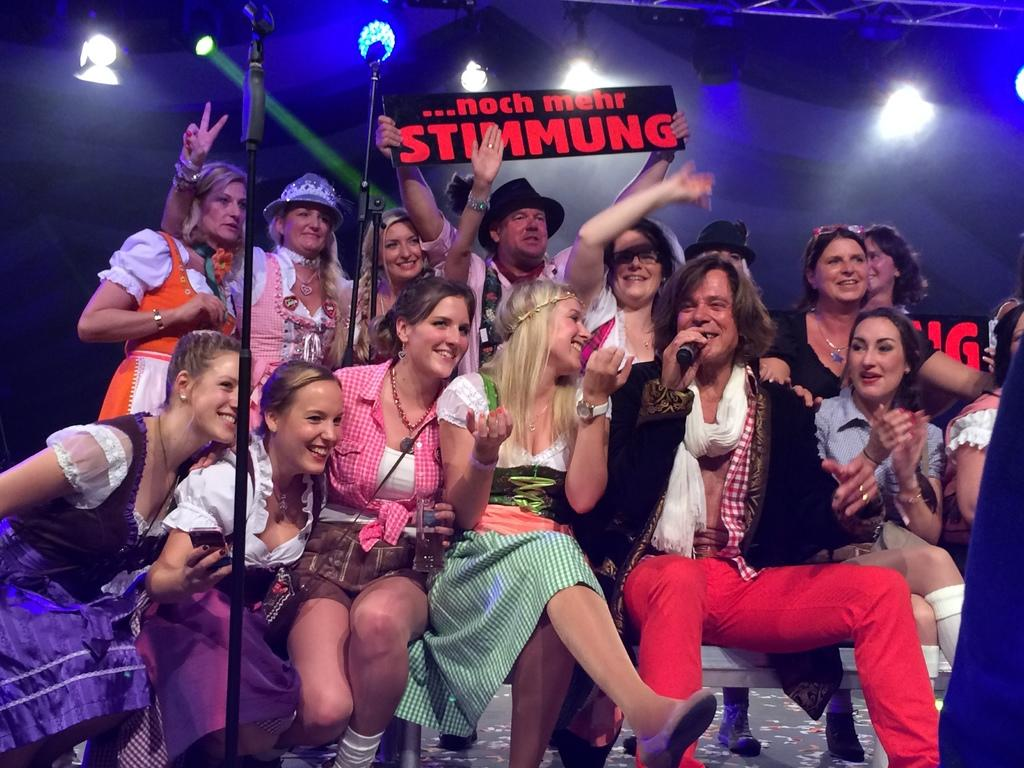What are the people in the image doing? The people in the image are sitting and smiling. Are there any people standing in the image? Yes, there are people standing in the image. What is the setting of the image? The image appears to be a stage or board. Who is holding a microphone in the image? A man is holding a microphone in the image. What can be seen in the background that might indicate a performance or event? There are show lights visible in the image. How many wrens can be seen flying around the stage in the image? There are no wrens visible in the image. What type of spiders are crawling on the microphone in the image? There are no spiders present in the image. 